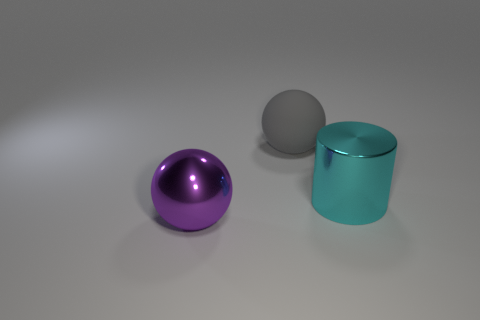What shape is the cyan object that is the same size as the gray rubber ball?
Keep it short and to the point. Cylinder. Are there fewer big gray spheres than metal things?
Ensure brevity in your answer.  Yes. There is a ball that is behind the purple ball; are there any spheres in front of it?
Ensure brevity in your answer.  Yes. There is a object that is the same material as the big cyan cylinder; what shape is it?
Your answer should be very brief. Sphere. There is a large gray object that is the same shape as the big purple shiny object; what is its material?
Offer a terse response. Rubber. How many other things are there of the same size as the metallic cylinder?
Ensure brevity in your answer.  2. There is a big shiny object in front of the cyan cylinder; is its shape the same as the big gray thing?
Provide a succinct answer. Yes. What number of other things are the same shape as the purple object?
Provide a succinct answer. 1. The large object in front of the cylinder has what shape?
Make the answer very short. Sphere. Is there a thing made of the same material as the gray ball?
Offer a very short reply. No. 